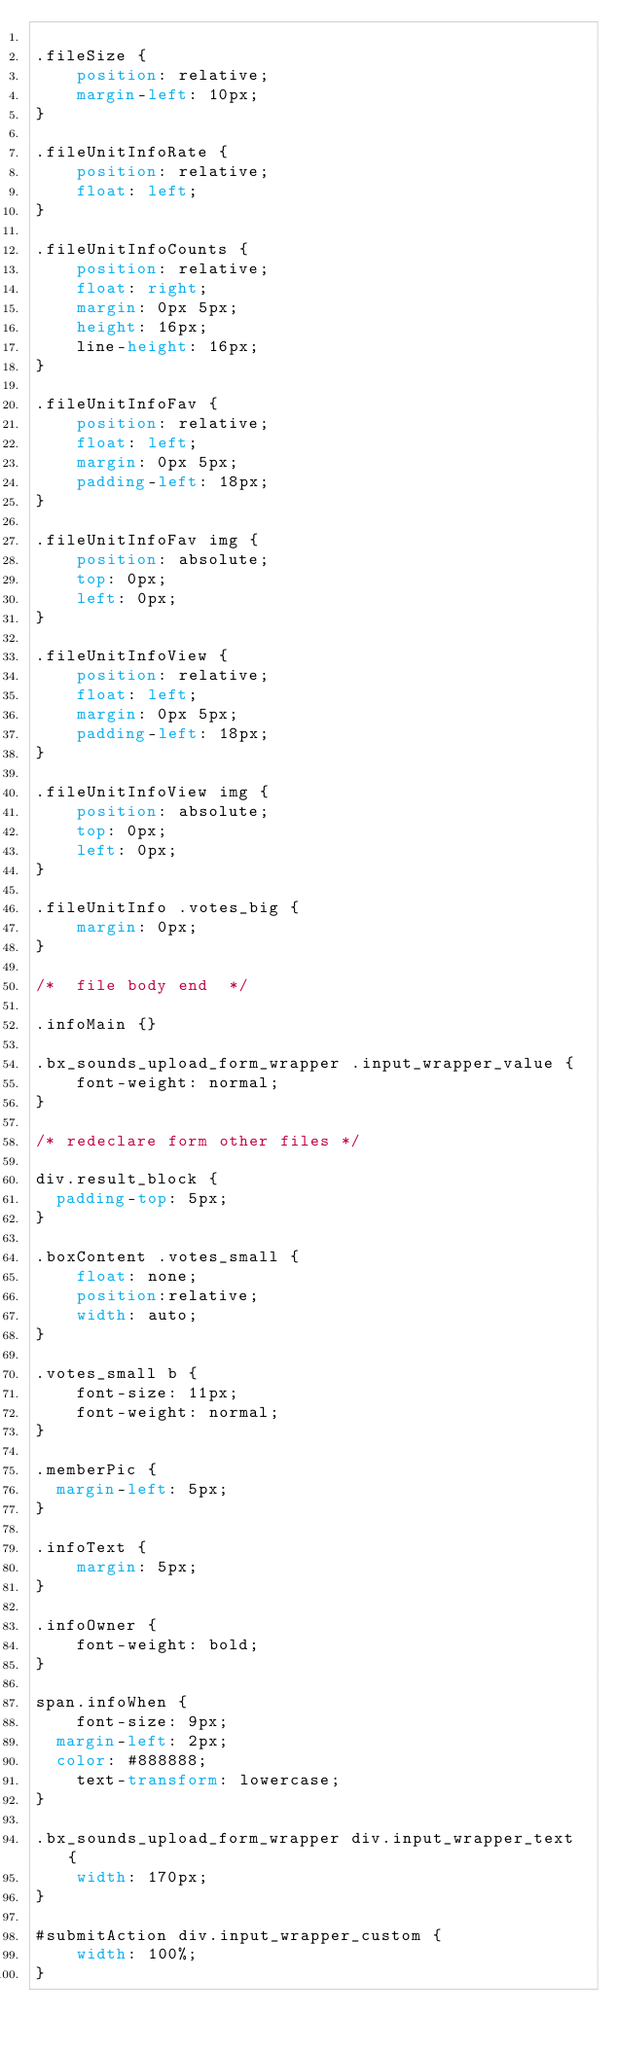<code> <loc_0><loc_0><loc_500><loc_500><_CSS_>
.fileSize {
    position: relative;
    margin-left: 10px;
}

.fileUnitInfoRate {
    position: relative;
    float: left;
}

.fileUnitInfoCounts {
    position: relative;
    float: right;
    margin: 0px 5px;
    height: 16px;
    line-height: 16px;
}

.fileUnitInfoFav {
    position: relative;
    float: left;
    margin: 0px 5px;
    padding-left: 18px;
}

.fileUnitInfoFav img {
    position: absolute;
    top: 0px;
    left: 0px;
}

.fileUnitInfoView {
    position: relative;
    float: left;
    margin: 0px 5px;
    padding-left: 18px;
}

.fileUnitInfoView img {
    position: absolute;
    top: 0px;
    left: 0px;
}

.fileUnitInfo .votes_big {
    margin: 0px;
}

/*  file body end  */

.infoMain {}

.bx_sounds_upload_form_wrapper .input_wrapper_value {
    font-weight: normal;
}

/* redeclare form other files */

div.result_block {
	padding-top: 5px;
}

.boxContent .votes_small {
    float: none;
    position:relative;
    width: auto;
}

.votes_small b {
    font-size: 11px;
    font-weight: normal;
}

.memberPic {
	margin-left: 5px;
}

.infoText {
    margin: 5px;
}

.infoOwner {
    font-weight: bold;
}

span.infoWhen {
    font-size: 9px;
	margin-left: 2px;
	color: #888888;
    text-transform: lowercase;
}

.bx_sounds_upload_form_wrapper div.input_wrapper_text {
    width: 170px;
}

#submitAction div.input_wrapper_custom {
    width: 100%;
}
</code> 